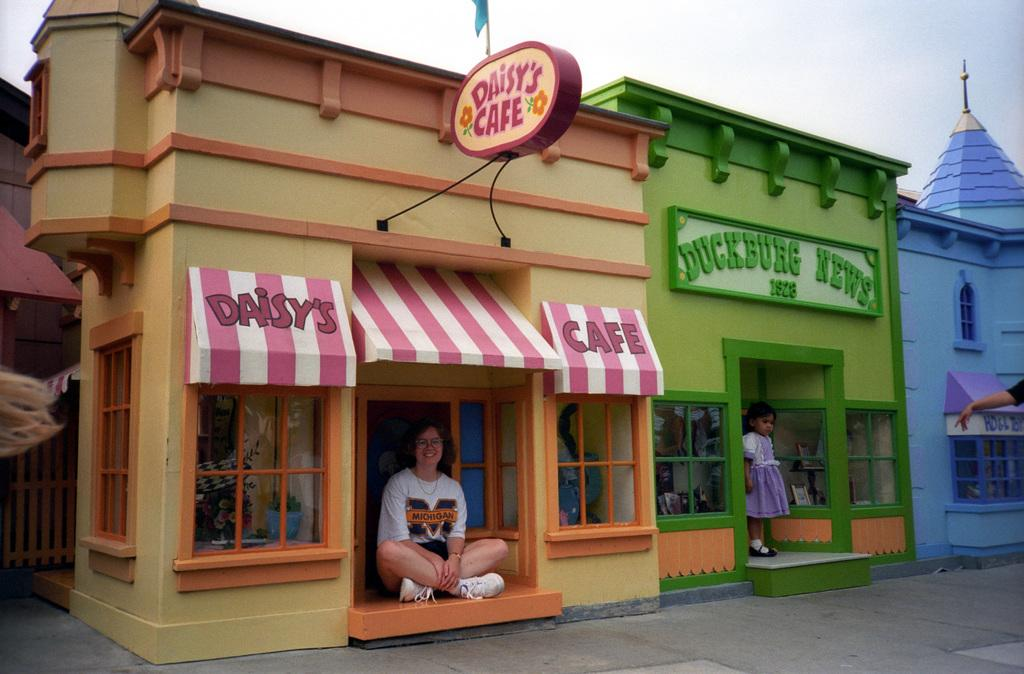Who are the people in the image? There is a woman and a girl in the image. What are the woman and the girl doing in the image? The woman and the girl are posing in the image. What is the background of the image? The woman and the girl are posing in front of miniature homes. What type of hammer is the woman holding in the image? There is no hammer present in the image. What color is the chalk that the girl is drawing with in the image? There is no chalk or drawing activity present in the image. Can you describe the type of kiss the woman and the girl are sharing in the image? There is no kiss present in the image; the woman and the girl are posing. 